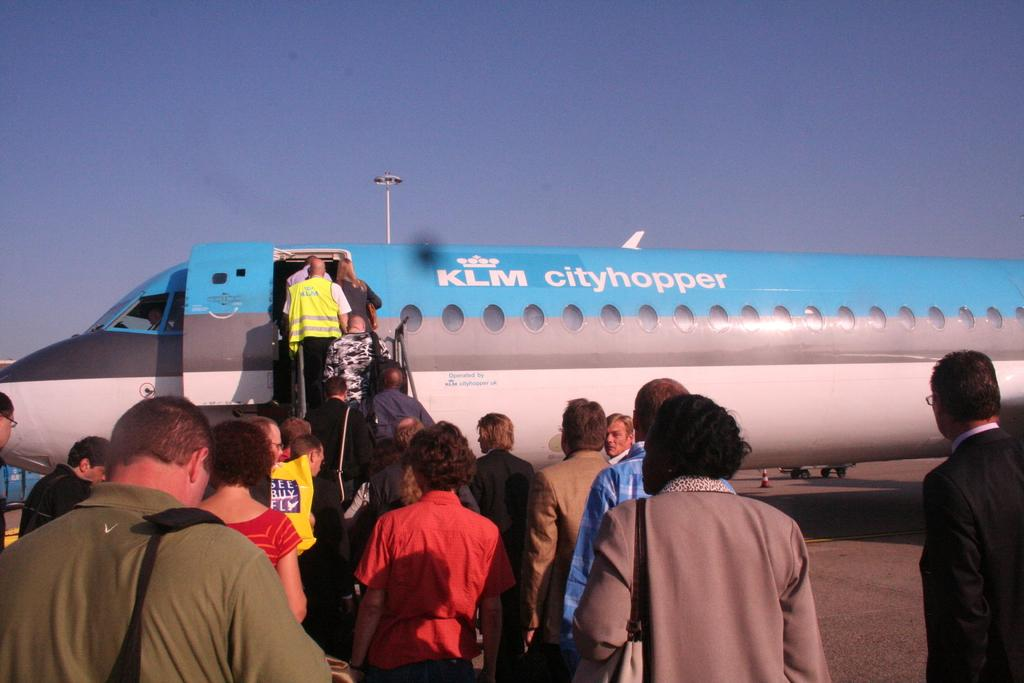What is the main subject of the image? The main subject of the image is an airplane. What are the people in the image doing? People are boarding the airplane. What type of vegetable is being used as a prop in the image? There is no vegetable present in the image; it features an airplane and people boarding it. 